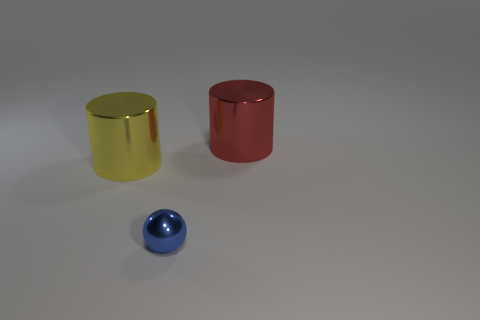Which of these objects is the largest? The red cylinder appears to be the largest of the three objects in terms of height and volume. 